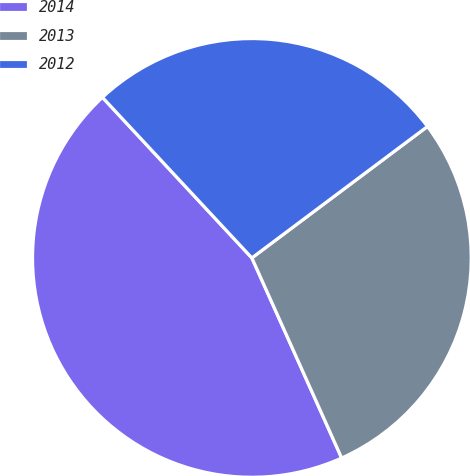<chart> <loc_0><loc_0><loc_500><loc_500><pie_chart><fcel>2014<fcel>2013<fcel>2012<nl><fcel>44.78%<fcel>28.51%<fcel>26.7%<nl></chart> 